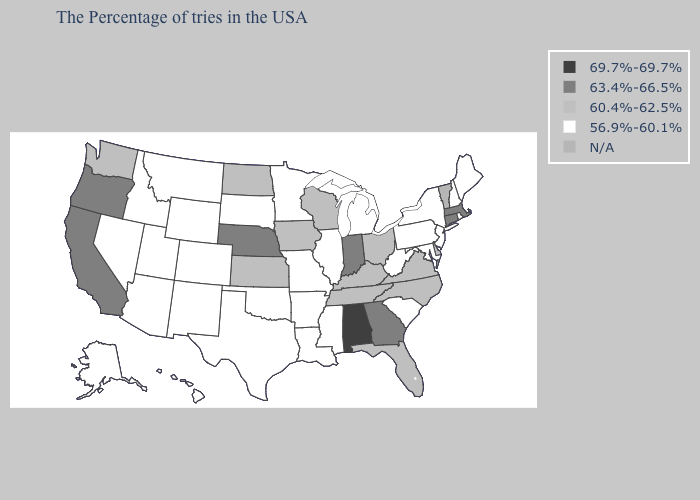Among the states that border Minnesota , which have the lowest value?
Keep it brief. South Dakota. Does Alaska have the lowest value in the West?
Give a very brief answer. Yes. What is the lowest value in the USA?
Keep it brief. 56.9%-60.1%. What is the highest value in the USA?
Give a very brief answer. 69.7%-69.7%. Which states hav the highest value in the Northeast?
Be succinct. Massachusetts, Connecticut. Among the states that border Indiana , does Illinois have the highest value?
Keep it brief. No. Which states have the lowest value in the West?
Keep it brief. Wyoming, Colorado, New Mexico, Utah, Montana, Arizona, Idaho, Nevada, Alaska, Hawaii. Name the states that have a value in the range 63.4%-66.5%?
Be succinct. Massachusetts, Connecticut, Georgia, Indiana, Nebraska, California, Oregon. Name the states that have a value in the range 69.7%-69.7%?
Write a very short answer. Alabama. Name the states that have a value in the range 69.7%-69.7%?
Keep it brief. Alabama. Name the states that have a value in the range 69.7%-69.7%?
Answer briefly. Alabama. 